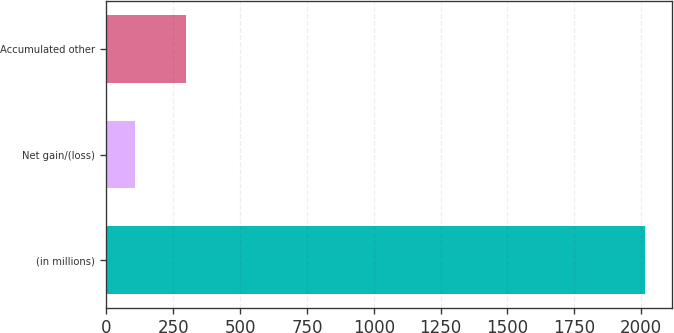Convert chart to OTSL. <chart><loc_0><loc_0><loc_500><loc_500><bar_chart><fcel>(in millions)<fcel>Net gain/(loss)<fcel>Accumulated other<nl><fcel>2015<fcel>109<fcel>299.6<nl></chart> 